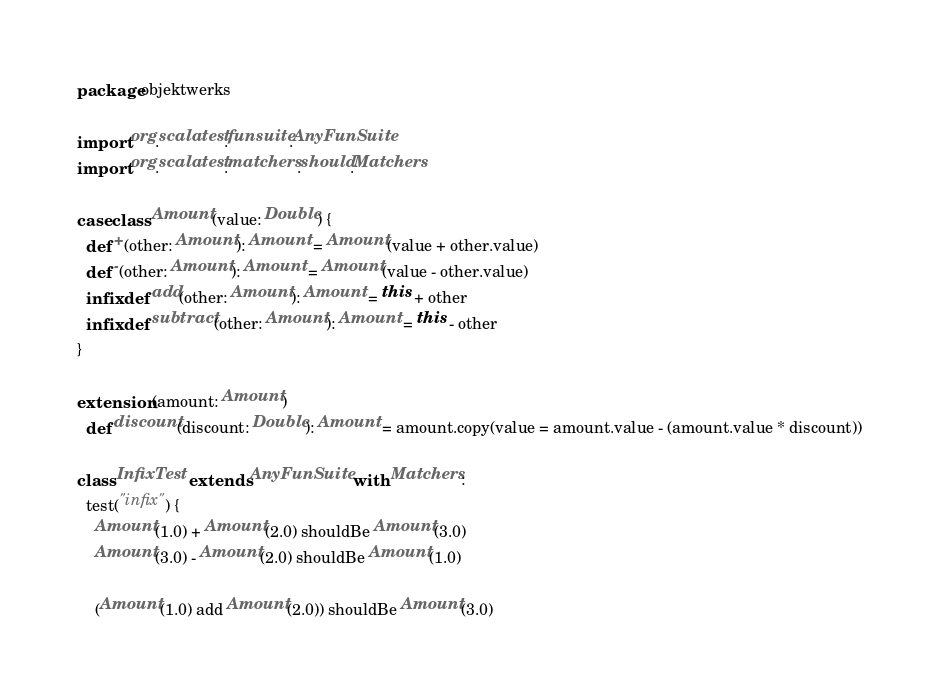Convert code to text. <code><loc_0><loc_0><loc_500><loc_500><_Scala_>package objektwerks

import org.scalatest.funsuite.AnyFunSuite
import org.scalatest.matchers.should.Matchers

case class Amount(value: Double) {
  def +(other: Amount): Amount = Amount(value + other.value)
  def -(other: Amount): Amount = Amount(value - other.value)
  infix def add(other: Amount): Amount = this + other
  infix def subtract(other: Amount): Amount = this - other
}

extension (amount: Amount)
  def discount(discount: Double): Amount = amount.copy(value = amount.value - (amount.value * discount))

class InfixTest extends AnyFunSuite with Matchers:
  test("infix") {
    Amount(1.0) + Amount(2.0) shouldBe Amount(3.0)
    Amount(3.0) - Amount(2.0) shouldBe Amount(1.0)

    (Amount(1.0) add Amount(2.0)) shouldBe Amount(3.0)</code> 